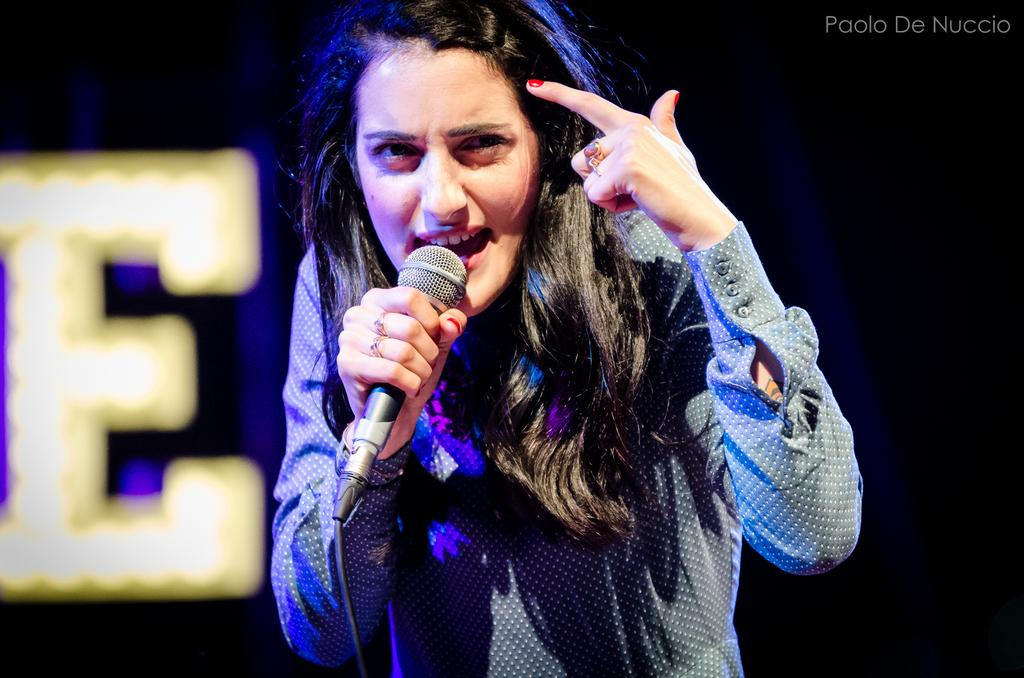Who is the main subject in the image? There is a woman in the image. What is the woman holding in her hand? The woman is holding a microphone (mike) in her hand. What is the date of the event taking place at the airport in the image? There is no event or airport present in the image; it only features a woman holding a microphone. 